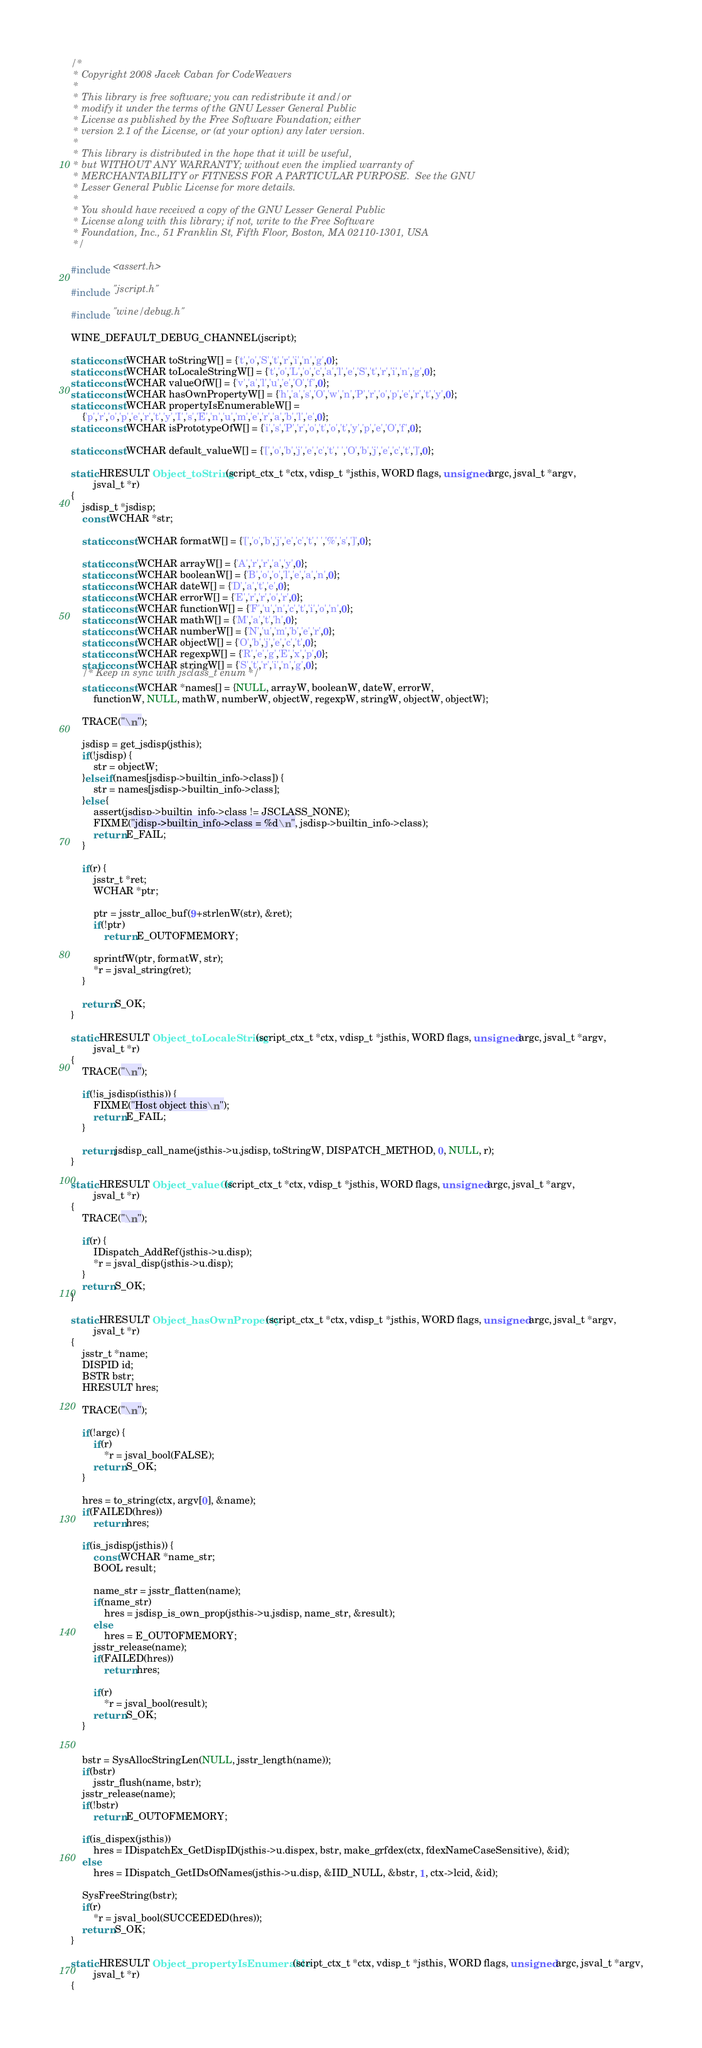Convert code to text. <code><loc_0><loc_0><loc_500><loc_500><_C_>/*
 * Copyright 2008 Jacek Caban for CodeWeavers
 *
 * This library is free software; you can redistribute it and/or
 * modify it under the terms of the GNU Lesser General Public
 * License as published by the Free Software Foundation; either
 * version 2.1 of the License, or (at your option) any later version.
 *
 * This library is distributed in the hope that it will be useful,
 * but WITHOUT ANY WARRANTY; without even the implied warranty of
 * MERCHANTABILITY or FITNESS FOR A PARTICULAR PURPOSE.  See the GNU
 * Lesser General Public License for more details.
 *
 * You should have received a copy of the GNU Lesser General Public
 * License along with this library; if not, write to the Free Software
 * Foundation, Inc., 51 Franklin St, Fifth Floor, Boston, MA 02110-1301, USA
 */

#include <assert.h>

#include "jscript.h"

#include "wine/debug.h"

WINE_DEFAULT_DEBUG_CHANNEL(jscript);

static const WCHAR toStringW[] = {'t','o','S','t','r','i','n','g',0};
static const WCHAR toLocaleStringW[] = {'t','o','L','o','c','a','l','e','S','t','r','i','n','g',0};
static const WCHAR valueOfW[] = {'v','a','l','u','e','O','f',0};
static const WCHAR hasOwnPropertyW[] = {'h','a','s','O','w','n','P','r','o','p','e','r','t','y',0};
static const WCHAR propertyIsEnumerableW[] =
    {'p','r','o','p','e','r','t','y','I','s','E','n','u','m','e','r','a','b','l','e',0};
static const WCHAR isPrototypeOfW[] = {'i','s','P','r','o','t','o','t','y','p','e','O','f',0};

static const WCHAR default_valueW[] = {'[','o','b','j','e','c','t',' ','O','b','j','e','c','t',']',0};

static HRESULT Object_toString(script_ctx_t *ctx, vdisp_t *jsthis, WORD flags, unsigned argc, jsval_t *argv,
        jsval_t *r)
{
    jsdisp_t *jsdisp;
    const WCHAR *str;

    static const WCHAR formatW[] = {'[','o','b','j','e','c','t',' ','%','s',']',0};

    static const WCHAR arrayW[] = {'A','r','r','a','y',0};
    static const WCHAR booleanW[] = {'B','o','o','l','e','a','n',0};
    static const WCHAR dateW[] = {'D','a','t','e',0};
    static const WCHAR errorW[] = {'E','r','r','o','r',0};
    static const WCHAR functionW[] = {'F','u','n','c','t','i','o','n',0};
    static const WCHAR mathW[] = {'M','a','t','h',0};
    static const WCHAR numberW[] = {'N','u','m','b','e','r',0};
    static const WCHAR objectW[] = {'O','b','j','e','c','t',0};
    static const WCHAR regexpW[] = {'R','e','g','E','x','p',0};
    static const WCHAR stringW[] = {'S','t','r','i','n','g',0};
    /* Keep in sync with jsclass_t enum */
    static const WCHAR *names[] = {NULL, arrayW, booleanW, dateW, errorW,
        functionW, NULL, mathW, numberW, objectW, regexpW, stringW, objectW, objectW};

    TRACE("\n");

    jsdisp = get_jsdisp(jsthis);
    if(!jsdisp) {
        str = objectW;
    }else if(names[jsdisp->builtin_info->class]) {
        str = names[jsdisp->builtin_info->class];
    }else {
        assert(jsdisp->builtin_info->class != JSCLASS_NONE);
        FIXME("jdisp->builtin_info->class = %d\n", jsdisp->builtin_info->class);
        return E_FAIL;
    }

    if(r) {
        jsstr_t *ret;
        WCHAR *ptr;

        ptr = jsstr_alloc_buf(9+strlenW(str), &ret);
        if(!ptr)
            return E_OUTOFMEMORY;

        sprintfW(ptr, formatW, str);
        *r = jsval_string(ret);
    }

    return S_OK;
}

static HRESULT Object_toLocaleString(script_ctx_t *ctx, vdisp_t *jsthis, WORD flags, unsigned argc, jsval_t *argv,
        jsval_t *r)
{
    TRACE("\n");

    if(!is_jsdisp(jsthis)) {
        FIXME("Host object this\n");
        return E_FAIL;
    }

    return jsdisp_call_name(jsthis->u.jsdisp, toStringW, DISPATCH_METHOD, 0, NULL, r);
}

static HRESULT Object_valueOf(script_ctx_t *ctx, vdisp_t *jsthis, WORD flags, unsigned argc, jsval_t *argv,
        jsval_t *r)
{
    TRACE("\n");

    if(r) {
        IDispatch_AddRef(jsthis->u.disp);
        *r = jsval_disp(jsthis->u.disp);
    }
    return S_OK;
}

static HRESULT Object_hasOwnProperty(script_ctx_t *ctx, vdisp_t *jsthis, WORD flags, unsigned argc, jsval_t *argv,
        jsval_t *r)
{
    jsstr_t *name;
    DISPID id;
    BSTR bstr;
    HRESULT hres;

    TRACE("\n");

    if(!argc) {
        if(r)
            *r = jsval_bool(FALSE);
        return S_OK;
    }

    hres = to_string(ctx, argv[0], &name);
    if(FAILED(hres))
        return hres;

    if(is_jsdisp(jsthis)) {
        const WCHAR *name_str;
        BOOL result;

        name_str = jsstr_flatten(name);
        if(name_str)
            hres = jsdisp_is_own_prop(jsthis->u.jsdisp, name_str, &result);
        else
            hres = E_OUTOFMEMORY;
        jsstr_release(name);
        if(FAILED(hres))
            return hres;

        if(r)
            *r = jsval_bool(result);
        return S_OK;
    }


    bstr = SysAllocStringLen(NULL, jsstr_length(name));
    if(bstr)
        jsstr_flush(name, bstr);
    jsstr_release(name);
    if(!bstr)
        return E_OUTOFMEMORY;

    if(is_dispex(jsthis))
        hres = IDispatchEx_GetDispID(jsthis->u.dispex, bstr, make_grfdex(ctx, fdexNameCaseSensitive), &id);
    else
        hres = IDispatch_GetIDsOfNames(jsthis->u.disp, &IID_NULL, &bstr, 1, ctx->lcid, &id);

    SysFreeString(bstr);
    if(r)
        *r = jsval_bool(SUCCEEDED(hres));
    return S_OK;
}

static HRESULT Object_propertyIsEnumerable(script_ctx_t *ctx, vdisp_t *jsthis, WORD flags, unsigned argc, jsval_t *argv,
        jsval_t *r)
{</code> 